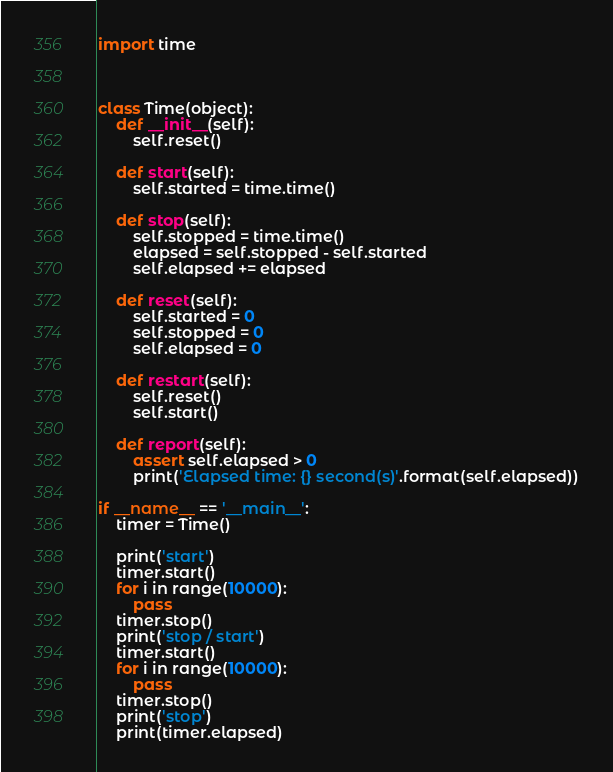<code> <loc_0><loc_0><loc_500><loc_500><_Python_>import time



class Time(object):
    def __init__(self):
        self.reset()

    def start(self):
        self.started = time.time()

    def stop(self):
        self.stopped = time.time()
        elapsed = self.stopped - self.started
        self.elapsed += elapsed

    def reset(self):
        self.started = 0
        self.stopped = 0
        self.elapsed = 0

    def restart(self):
        self.reset()
        self.start()

    def report(self):
        assert self.elapsed > 0
        print('Elapsed time: {} second(s)'.format(self.elapsed))

if __name__ == '__main__':
    timer = Time()

    print('start')
    timer.start()
    for i in range(10000):
        pass
    timer.stop()
    print('stop / start')
    timer.start()
    for i in range(10000):
        pass
    timer.stop()
    print('stop')
    print(timer.elapsed)
</code> 